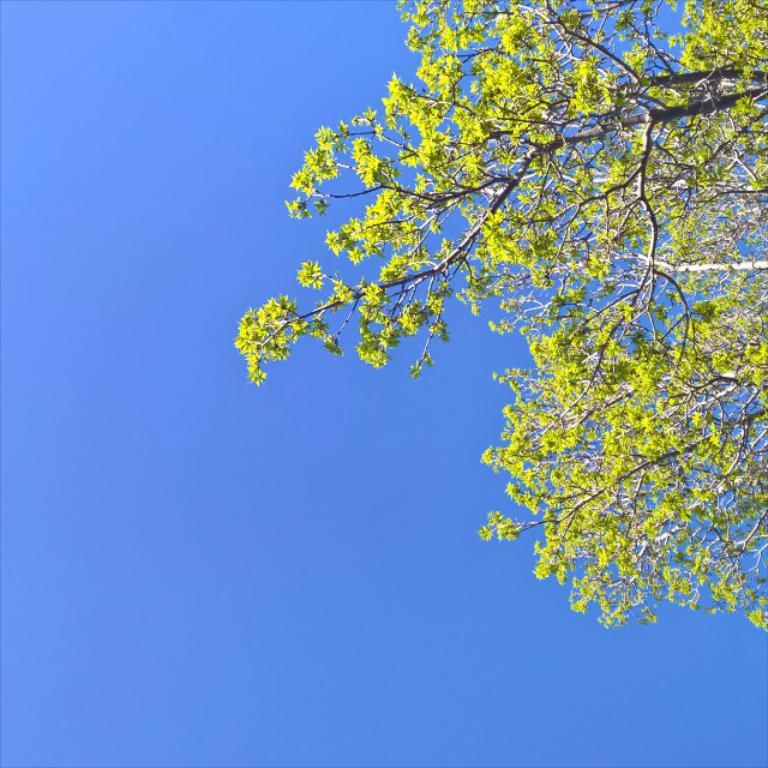What is the main object in the image? There is a tree in the image. What can be seen on the tree? There are flowers on the tree. What color are the flowers? The flowers are yellow in color. What can be seen in the background of the image? The sky is visible in the background of the image. What color is the sky? The sky is blue in color. Is there a swing hanging from the tree in the image? No, there is no swing present in the image. Can you see a ship sailing in the blue sky in the image? No, there is no ship visible in the image; only the tree, flowers, and sky are present. 